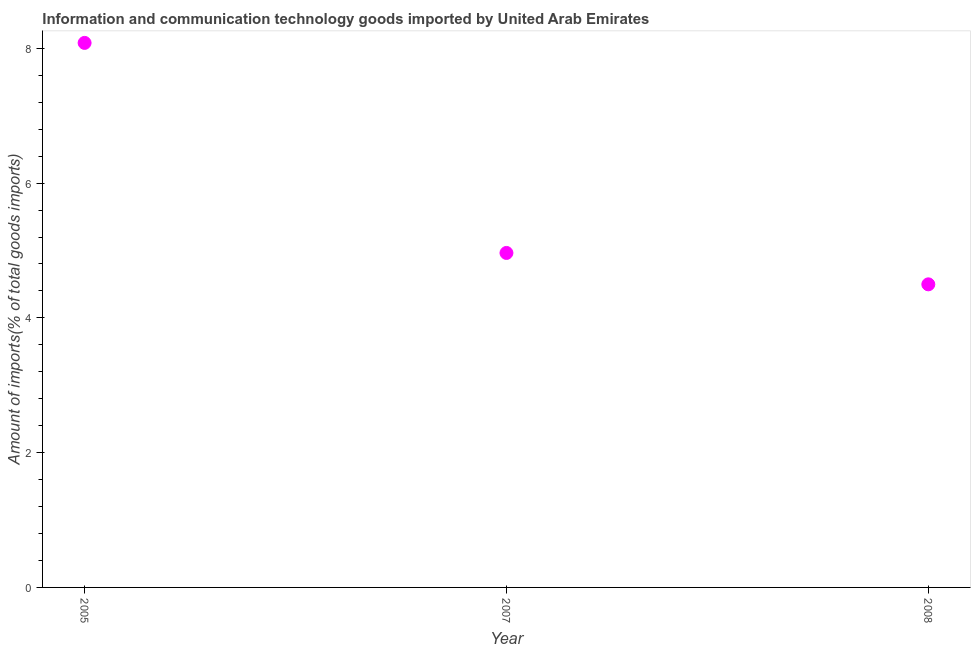What is the amount of ict goods imports in 2007?
Ensure brevity in your answer.  4.96. Across all years, what is the maximum amount of ict goods imports?
Offer a terse response. 8.08. Across all years, what is the minimum amount of ict goods imports?
Give a very brief answer. 4.5. What is the sum of the amount of ict goods imports?
Your answer should be compact. 17.54. What is the difference between the amount of ict goods imports in 2005 and 2008?
Offer a terse response. 3.58. What is the average amount of ict goods imports per year?
Give a very brief answer. 5.85. What is the median amount of ict goods imports?
Give a very brief answer. 4.96. In how many years, is the amount of ict goods imports greater than 3.6 %?
Your answer should be compact. 3. What is the ratio of the amount of ict goods imports in 2005 to that in 2007?
Keep it short and to the point. 1.63. What is the difference between the highest and the second highest amount of ict goods imports?
Give a very brief answer. 3.12. What is the difference between the highest and the lowest amount of ict goods imports?
Your answer should be compact. 3.58. Does the amount of ict goods imports monotonically increase over the years?
Make the answer very short. No. How many dotlines are there?
Give a very brief answer. 1. Are the values on the major ticks of Y-axis written in scientific E-notation?
Offer a terse response. No. Does the graph contain grids?
Your answer should be compact. No. What is the title of the graph?
Offer a very short reply. Information and communication technology goods imported by United Arab Emirates. What is the label or title of the Y-axis?
Ensure brevity in your answer.  Amount of imports(% of total goods imports). What is the Amount of imports(% of total goods imports) in 2005?
Your answer should be very brief. 8.08. What is the Amount of imports(% of total goods imports) in 2007?
Provide a succinct answer. 4.96. What is the Amount of imports(% of total goods imports) in 2008?
Provide a succinct answer. 4.5. What is the difference between the Amount of imports(% of total goods imports) in 2005 and 2007?
Offer a terse response. 3.12. What is the difference between the Amount of imports(% of total goods imports) in 2005 and 2008?
Offer a terse response. 3.58. What is the difference between the Amount of imports(% of total goods imports) in 2007 and 2008?
Provide a succinct answer. 0.47. What is the ratio of the Amount of imports(% of total goods imports) in 2005 to that in 2007?
Your response must be concise. 1.63. What is the ratio of the Amount of imports(% of total goods imports) in 2005 to that in 2008?
Your response must be concise. 1.8. What is the ratio of the Amount of imports(% of total goods imports) in 2007 to that in 2008?
Your response must be concise. 1.1. 